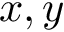<formula> <loc_0><loc_0><loc_500><loc_500>x , y</formula> 